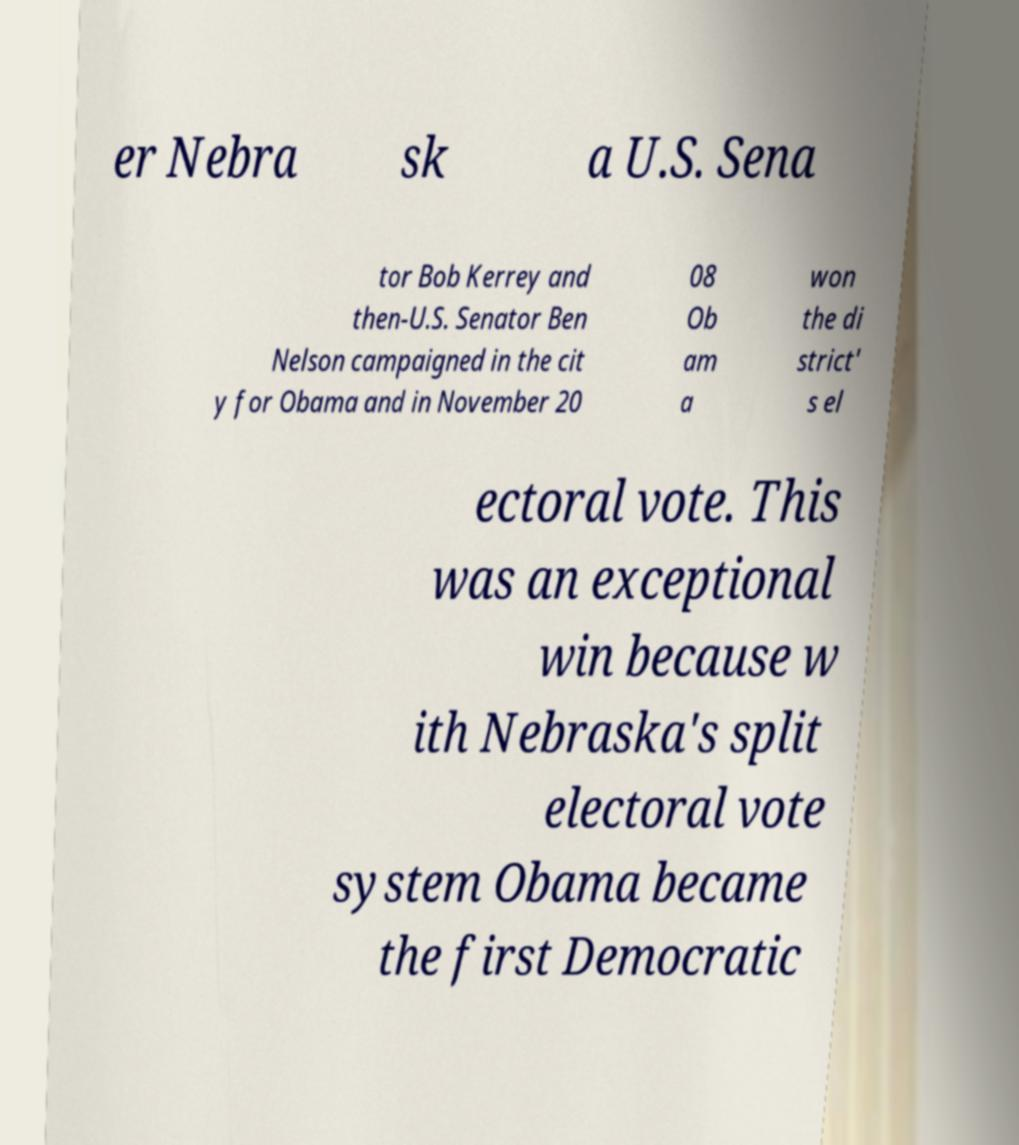For documentation purposes, I need the text within this image transcribed. Could you provide that? er Nebra sk a U.S. Sena tor Bob Kerrey and then-U.S. Senator Ben Nelson campaigned in the cit y for Obama and in November 20 08 Ob am a won the di strict' s el ectoral vote. This was an exceptional win because w ith Nebraska's split electoral vote system Obama became the first Democratic 